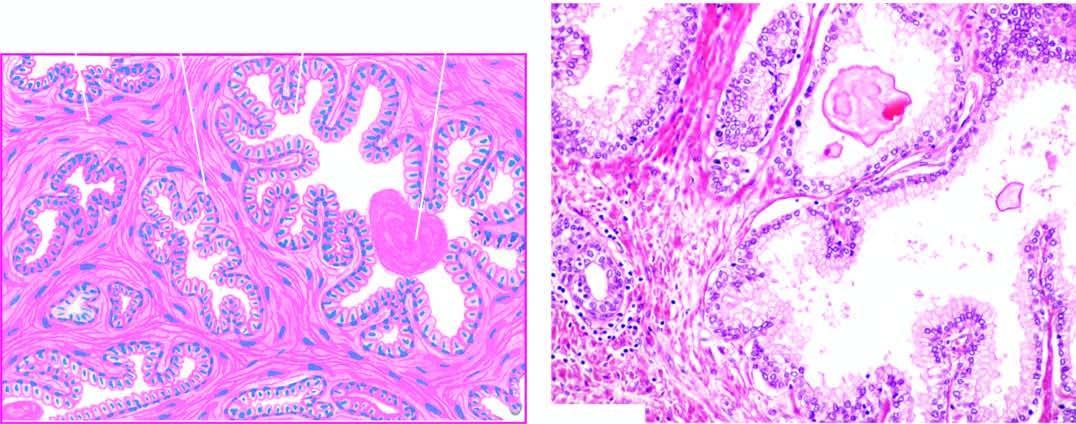re iron on absorption from upper small intestine areas of intra-acinar papillary infoldings lined by two layers of epithelium with basal polarity of nuclei?
Answer the question using a single word or phrase. No 